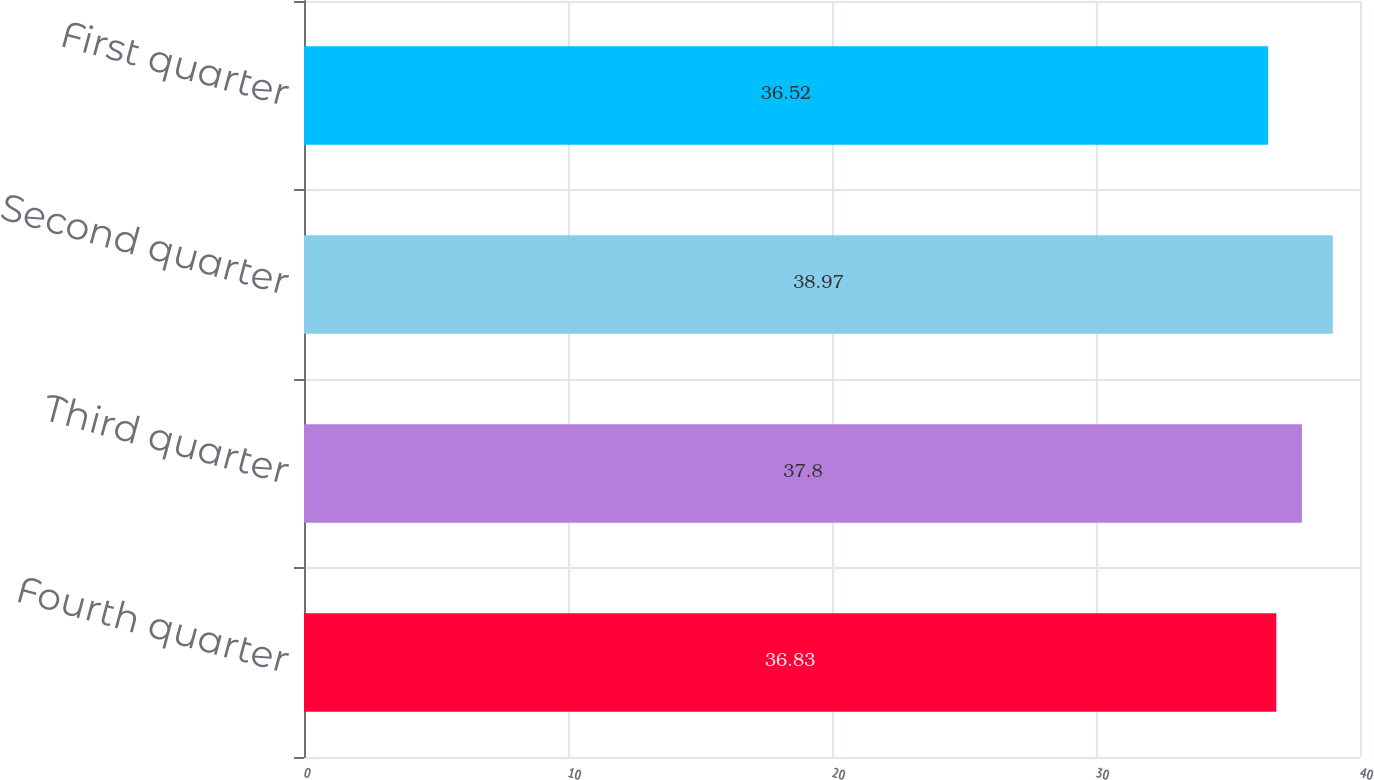<chart> <loc_0><loc_0><loc_500><loc_500><bar_chart><fcel>Fourth quarter<fcel>Third quarter<fcel>Second quarter<fcel>First quarter<nl><fcel>36.83<fcel>37.8<fcel>38.97<fcel>36.52<nl></chart> 